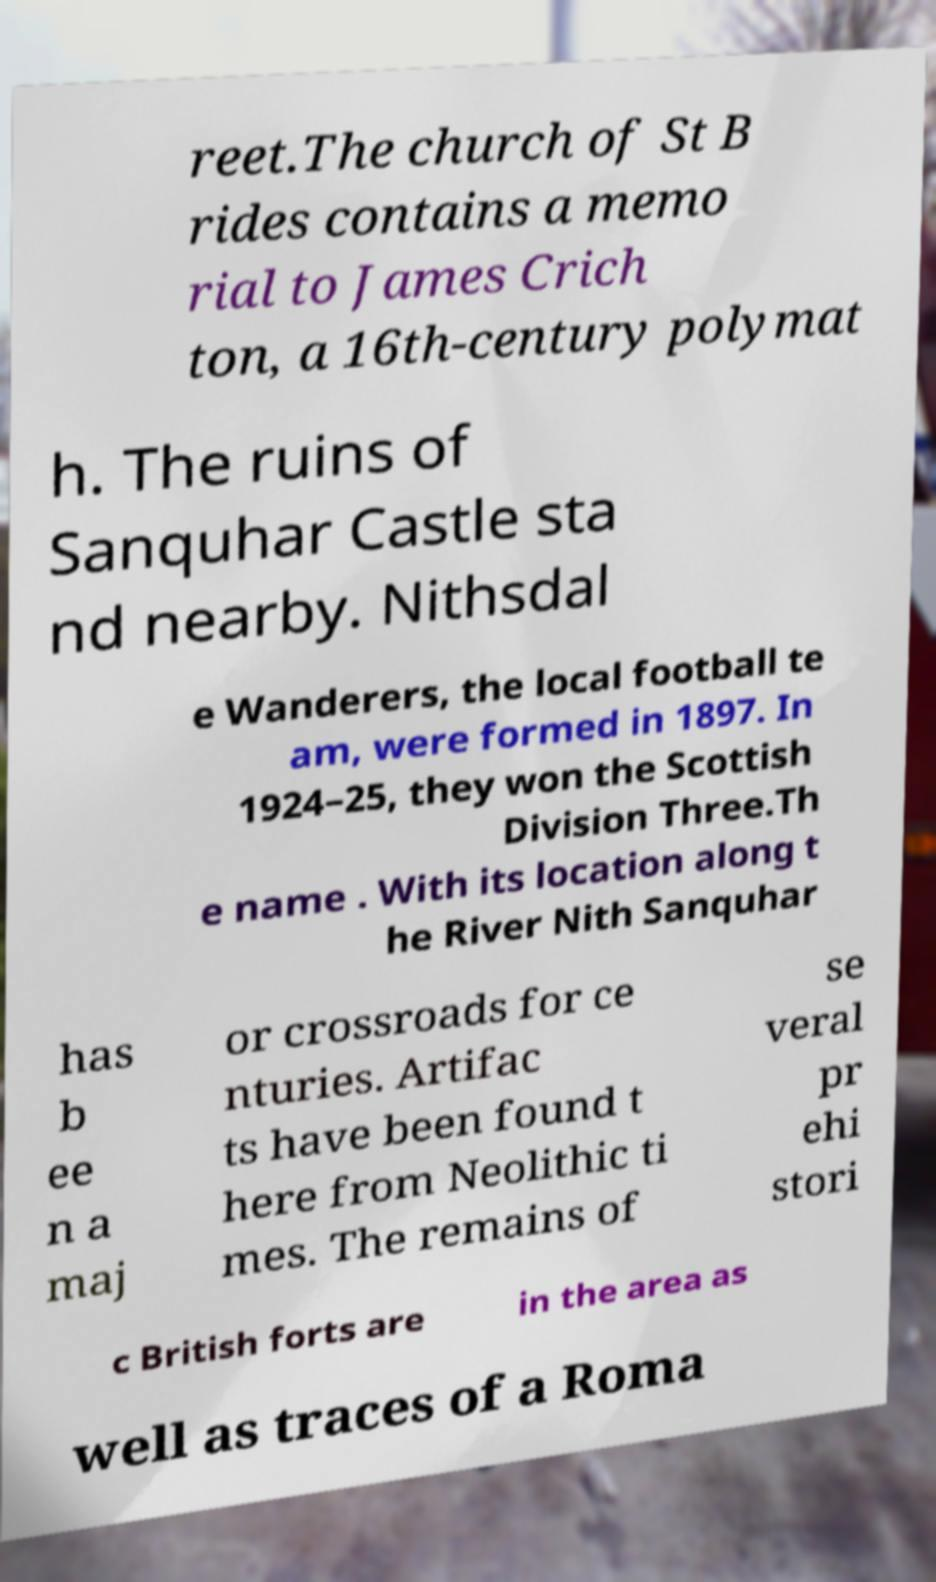Can you accurately transcribe the text from the provided image for me? reet.The church of St B rides contains a memo rial to James Crich ton, a 16th-century polymat h. The ruins of Sanquhar Castle sta nd nearby. Nithsdal e Wanderers, the local football te am, were formed in 1897. In 1924–25, they won the Scottish Division Three.Th e name . With its location along t he River Nith Sanquhar has b ee n a maj or crossroads for ce nturies. Artifac ts have been found t here from Neolithic ti mes. The remains of se veral pr ehi stori c British forts are in the area as well as traces of a Roma 